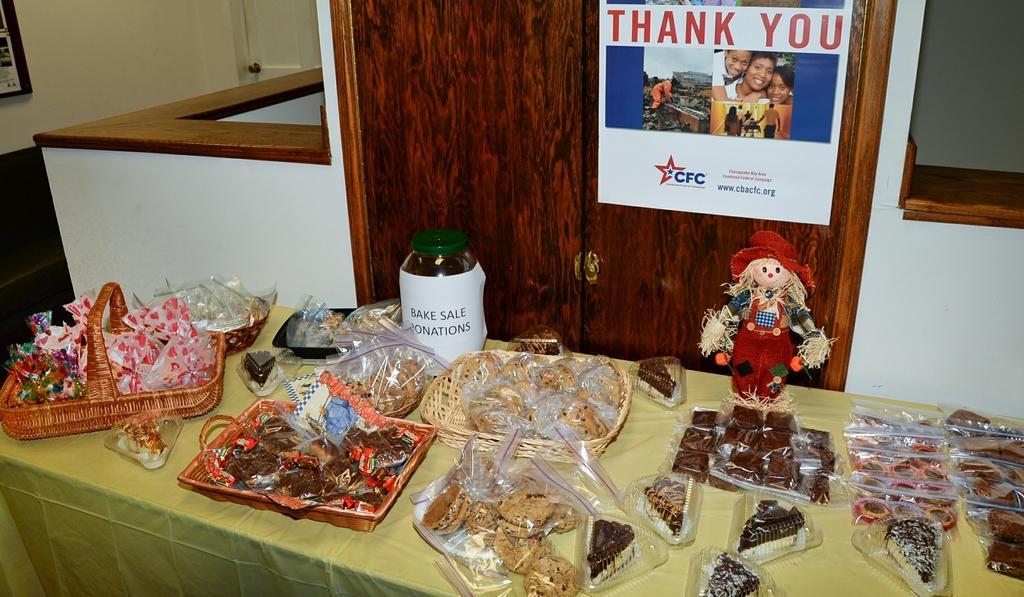Could you give a brief overview of what you see in this image? In this image we can see food items, basket, jar and a toy on the table. Behind the table, we can see cupboard and a table. On the cupboard we can see a poster with text and image. In the top left, we can see a wall and a door. On the top right, we can see a wall. 